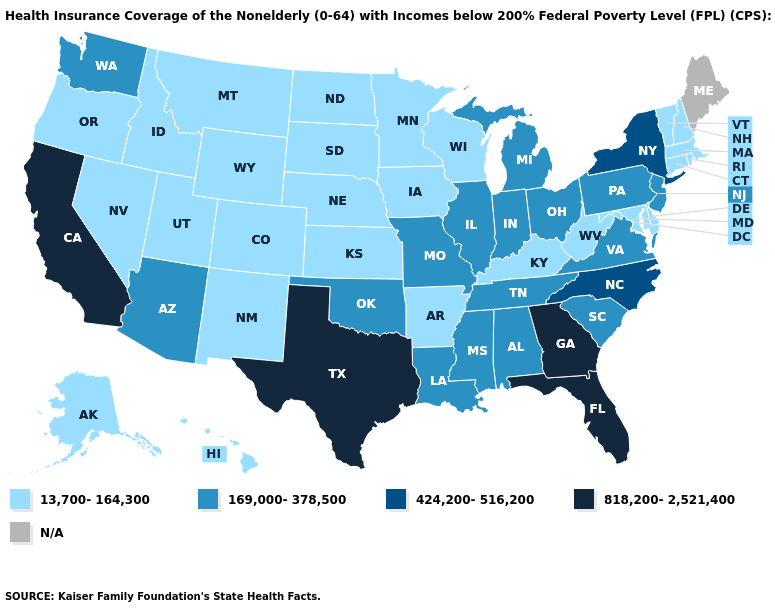How many symbols are there in the legend?
Be succinct. 5. Among the states that border Texas , which have the lowest value?
Quick response, please. Arkansas, New Mexico. What is the value of Missouri?
Answer briefly. 169,000-378,500. Does the map have missing data?
Keep it brief. Yes. Which states have the highest value in the USA?
Quick response, please. California, Florida, Georgia, Texas. Which states have the lowest value in the South?
Short answer required. Arkansas, Delaware, Kentucky, Maryland, West Virginia. Name the states that have a value in the range N/A?
Be succinct. Maine. Name the states that have a value in the range 169,000-378,500?
Give a very brief answer. Alabama, Arizona, Illinois, Indiana, Louisiana, Michigan, Mississippi, Missouri, New Jersey, Ohio, Oklahoma, Pennsylvania, South Carolina, Tennessee, Virginia, Washington. What is the lowest value in the South?
Write a very short answer. 13,700-164,300. Does Wyoming have the lowest value in the USA?
Give a very brief answer. Yes. Name the states that have a value in the range 13,700-164,300?
Keep it brief. Alaska, Arkansas, Colorado, Connecticut, Delaware, Hawaii, Idaho, Iowa, Kansas, Kentucky, Maryland, Massachusetts, Minnesota, Montana, Nebraska, Nevada, New Hampshire, New Mexico, North Dakota, Oregon, Rhode Island, South Dakota, Utah, Vermont, West Virginia, Wisconsin, Wyoming. 